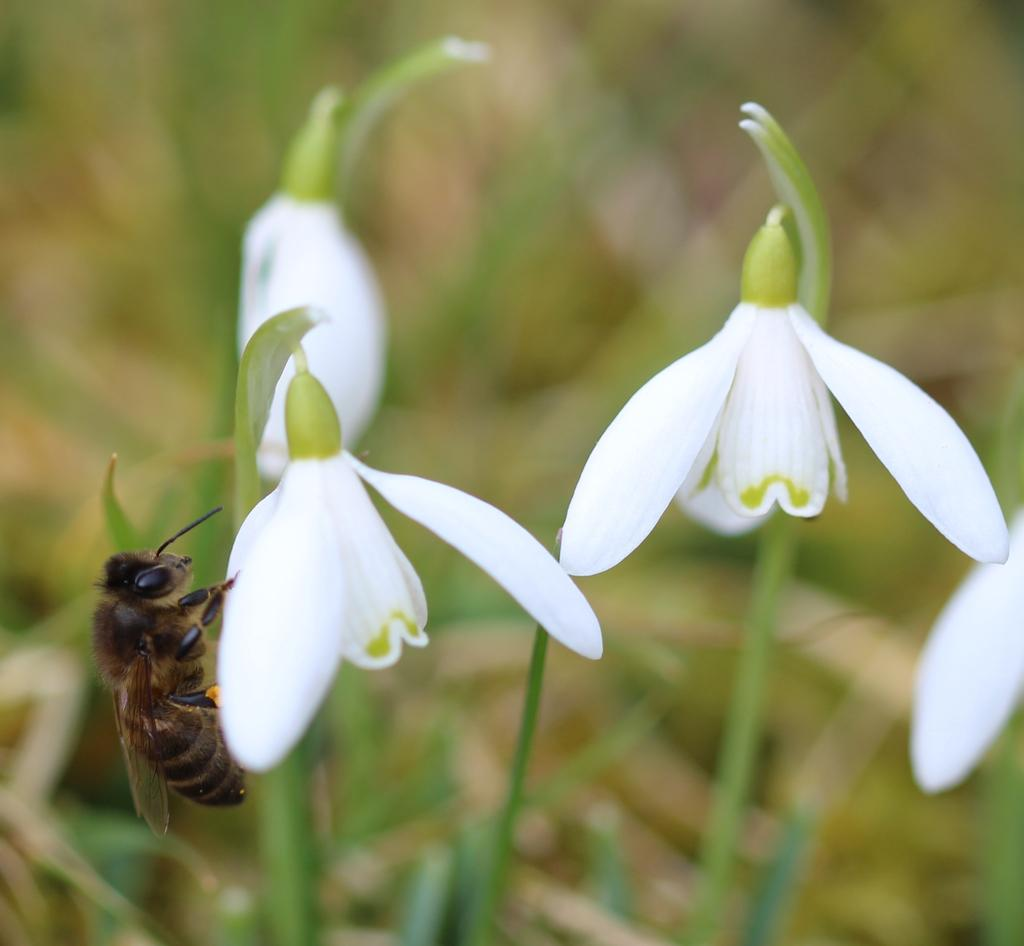What type of flowers are present in the image? There are white color flowers in the image. Can you describe any other living organisms in the image? Yes, there is an insect on one of the flowers. What can be observed about the background of the image? The background of the image is blurred. What type of laborer is working in the field in the image? There is no field or laborer present in the image; it features white color flowers and an insect. What answer is the cow providing in the image? There is no cow present in the image, so it cannot provide any answers. 